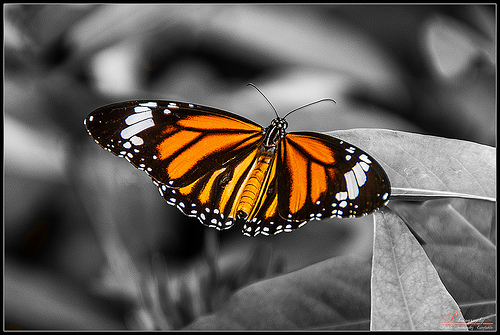<image>
Can you confirm if the wing is on the butterfly? Yes. Looking at the image, I can see the wing is positioned on top of the butterfly, with the butterfly providing support. 